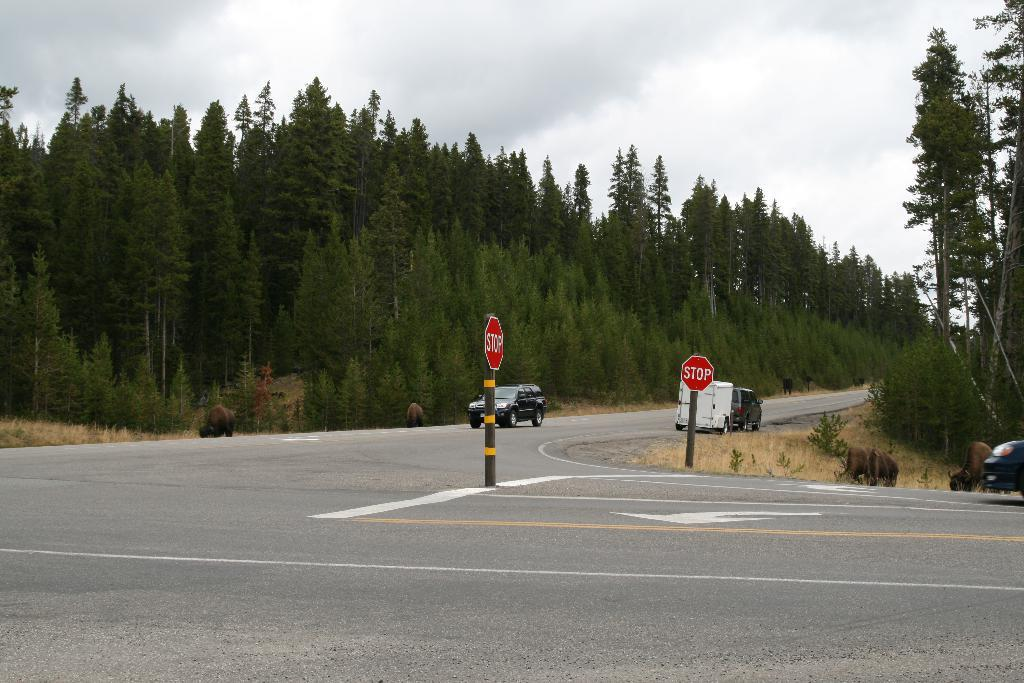What can be seen on the road in the image? There are vehicles on the road in the image. What is in front of the vehicles on the road? There are stop words in front of the vehicles. What is visible in the background of the image? There are trees and animals in the background of the image. Where is the sink located in the image? There is no sink present in the image. What type of addition is being made to the vehicles in the image? There is no addition being made to the vehicles in the image. 